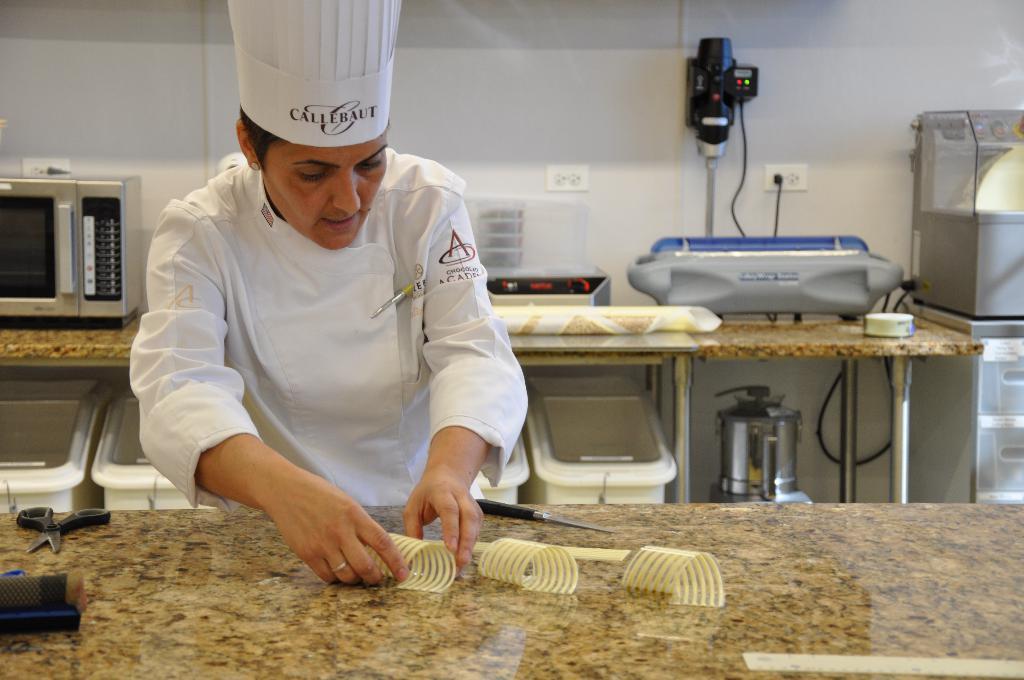Please provide a concise description of this image. In the image the chef is cooking some food item and in front of the chef there is a scissor and a knife. Behind the chef there is an oven and some cooking electronics. In the background there is a wall. 